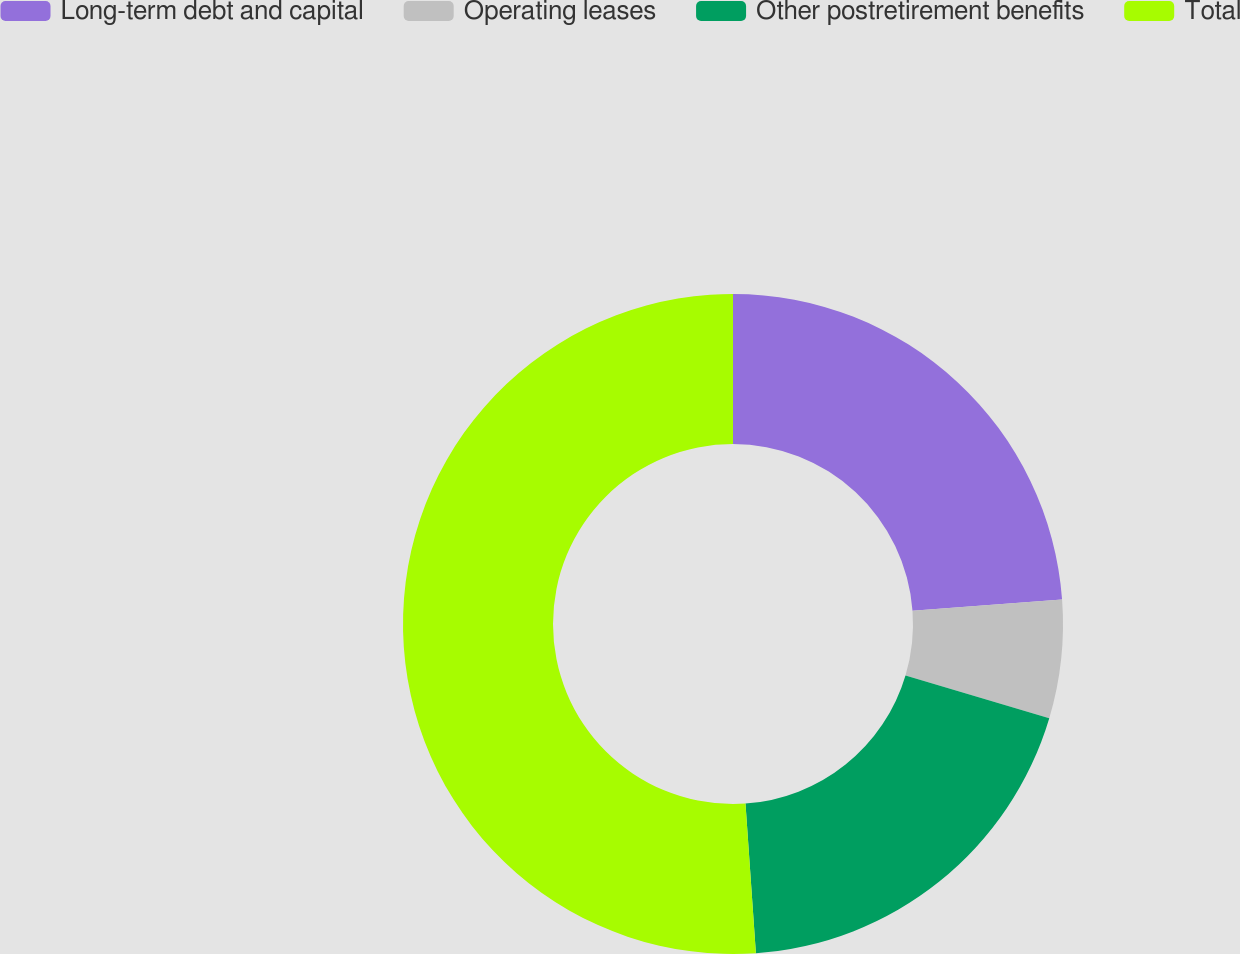Convert chart to OTSL. <chart><loc_0><loc_0><loc_500><loc_500><pie_chart><fcel>Long-term debt and capital<fcel>Operating leases<fcel>Other postretirement benefits<fcel>Total<nl><fcel>23.82%<fcel>5.79%<fcel>19.29%<fcel>51.11%<nl></chart> 